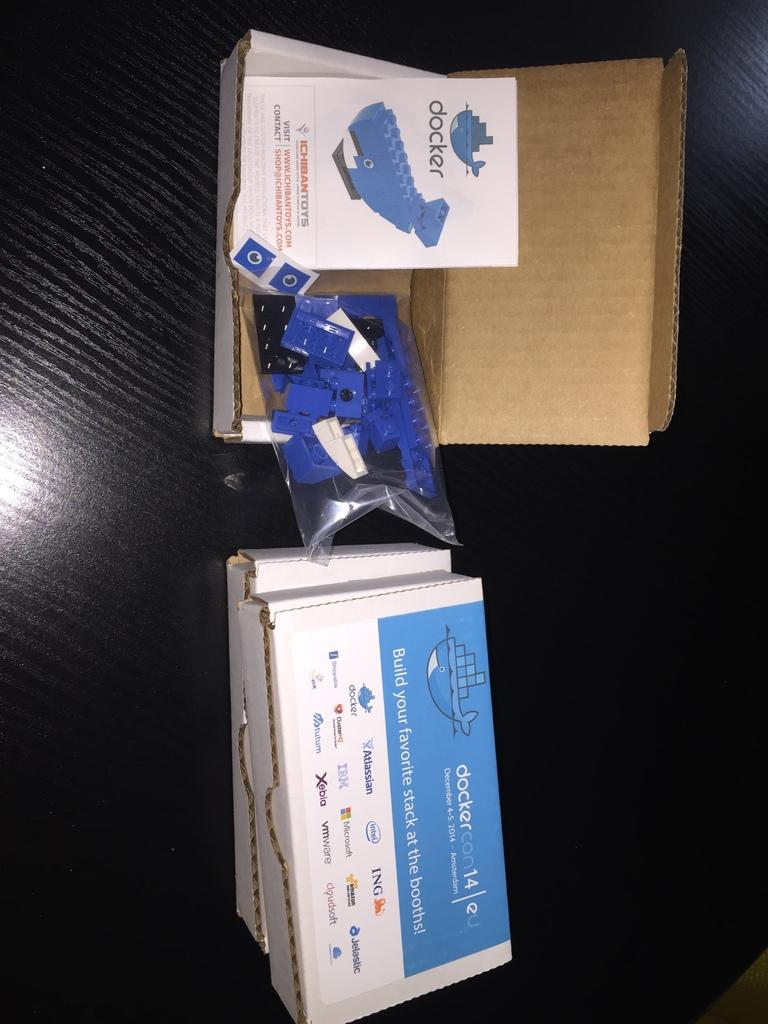Provide a one-sentence caption for the provided image. A toy box with Docker toys is opened and shows the instruction manual. 